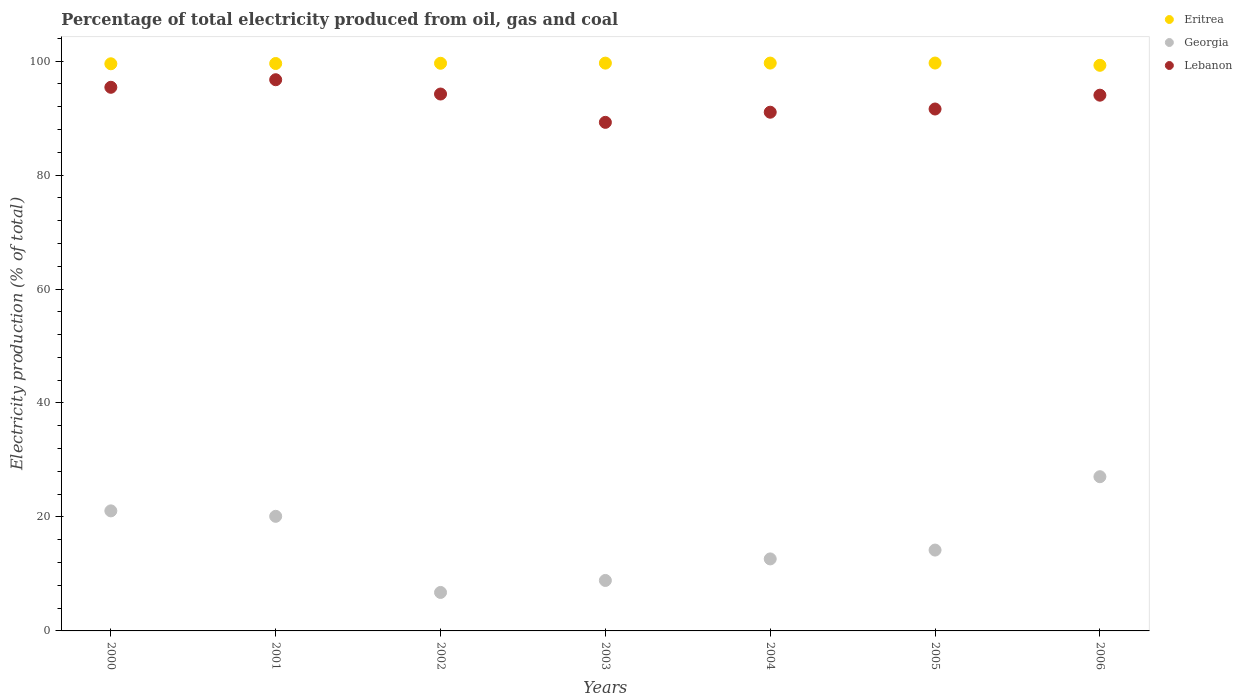How many different coloured dotlines are there?
Provide a short and direct response. 3. Is the number of dotlines equal to the number of legend labels?
Your answer should be very brief. Yes. What is the electricity production in in Eritrea in 2000?
Your answer should be compact. 99.52. Across all years, what is the maximum electricity production in in Georgia?
Provide a short and direct response. 27.06. Across all years, what is the minimum electricity production in in Lebanon?
Offer a very short reply. 89.25. In which year was the electricity production in in Lebanon maximum?
Ensure brevity in your answer.  2001. In which year was the electricity production in in Georgia minimum?
Give a very brief answer. 2002. What is the total electricity production in in Eritrea in the graph?
Give a very brief answer. 696.9. What is the difference between the electricity production in in Georgia in 2001 and that in 2006?
Your answer should be compact. -6.95. What is the difference between the electricity production in in Georgia in 2004 and the electricity production in in Eritrea in 2000?
Your answer should be compact. -86.89. What is the average electricity production in in Eritrea per year?
Offer a very short reply. 99.56. In the year 2001, what is the difference between the electricity production in in Lebanon and electricity production in in Georgia?
Offer a terse response. 76.62. What is the ratio of the electricity production in in Georgia in 2000 to that in 2004?
Make the answer very short. 1.67. Is the difference between the electricity production in in Lebanon in 2001 and 2003 greater than the difference between the electricity production in in Georgia in 2001 and 2003?
Your answer should be compact. No. What is the difference between the highest and the second highest electricity production in in Lebanon?
Provide a succinct answer. 1.33. What is the difference between the highest and the lowest electricity production in in Georgia?
Your answer should be compact. 20.31. In how many years, is the electricity production in in Georgia greater than the average electricity production in in Georgia taken over all years?
Keep it short and to the point. 3. Is it the case that in every year, the sum of the electricity production in in Georgia and electricity production in in Eritrea  is greater than the electricity production in in Lebanon?
Your answer should be very brief. Yes. Is the electricity production in in Eritrea strictly greater than the electricity production in in Lebanon over the years?
Make the answer very short. Yes. How many dotlines are there?
Ensure brevity in your answer.  3. How many years are there in the graph?
Offer a very short reply. 7. How many legend labels are there?
Your answer should be very brief. 3. What is the title of the graph?
Offer a terse response. Percentage of total electricity produced from oil, gas and coal. Does "France" appear as one of the legend labels in the graph?
Provide a short and direct response. No. What is the label or title of the Y-axis?
Offer a very short reply. Electricity production (% of total). What is the Electricity production (% of total) in Eritrea in 2000?
Keep it short and to the point. 99.52. What is the Electricity production (% of total) in Georgia in 2000?
Make the answer very short. 21.07. What is the Electricity production (% of total) in Lebanon in 2000?
Your answer should be compact. 95.4. What is the Electricity production (% of total) in Eritrea in 2001?
Offer a very short reply. 99.57. What is the Electricity production (% of total) in Georgia in 2001?
Make the answer very short. 20.11. What is the Electricity production (% of total) in Lebanon in 2001?
Your answer should be compact. 96.72. What is the Electricity production (% of total) of Eritrea in 2002?
Make the answer very short. 99.61. What is the Electricity production (% of total) in Georgia in 2002?
Offer a very short reply. 6.75. What is the Electricity production (% of total) in Lebanon in 2002?
Ensure brevity in your answer.  94.22. What is the Electricity production (% of total) in Eritrea in 2003?
Your answer should be very brief. 99.64. What is the Electricity production (% of total) of Georgia in 2003?
Provide a short and direct response. 8.85. What is the Electricity production (% of total) in Lebanon in 2003?
Offer a very short reply. 89.25. What is the Electricity production (% of total) of Eritrea in 2004?
Your response must be concise. 99.65. What is the Electricity production (% of total) of Georgia in 2004?
Provide a succinct answer. 12.64. What is the Electricity production (% of total) of Lebanon in 2004?
Make the answer very short. 91.02. What is the Electricity production (% of total) of Eritrea in 2005?
Provide a short and direct response. 99.65. What is the Electricity production (% of total) in Georgia in 2005?
Your response must be concise. 14.19. What is the Electricity production (% of total) of Lebanon in 2005?
Your answer should be compact. 91.59. What is the Electricity production (% of total) of Eritrea in 2006?
Provide a short and direct response. 99.26. What is the Electricity production (% of total) of Georgia in 2006?
Give a very brief answer. 27.06. What is the Electricity production (% of total) of Lebanon in 2006?
Ensure brevity in your answer.  94.01. Across all years, what is the maximum Electricity production (% of total) of Eritrea?
Provide a short and direct response. 99.65. Across all years, what is the maximum Electricity production (% of total) of Georgia?
Give a very brief answer. 27.06. Across all years, what is the maximum Electricity production (% of total) in Lebanon?
Your answer should be compact. 96.72. Across all years, what is the minimum Electricity production (% of total) of Eritrea?
Make the answer very short. 99.26. Across all years, what is the minimum Electricity production (% of total) of Georgia?
Your answer should be very brief. 6.75. Across all years, what is the minimum Electricity production (% of total) in Lebanon?
Your response must be concise. 89.25. What is the total Electricity production (% of total) in Eritrea in the graph?
Make the answer very short. 696.9. What is the total Electricity production (% of total) in Georgia in the graph?
Make the answer very short. 110.67. What is the total Electricity production (% of total) in Lebanon in the graph?
Ensure brevity in your answer.  652.21. What is the difference between the Electricity production (% of total) of Eritrea in 2000 and that in 2001?
Your response must be concise. -0.05. What is the difference between the Electricity production (% of total) of Georgia in 2000 and that in 2001?
Offer a very short reply. 0.96. What is the difference between the Electricity production (% of total) of Lebanon in 2000 and that in 2001?
Provide a short and direct response. -1.33. What is the difference between the Electricity production (% of total) of Eritrea in 2000 and that in 2002?
Provide a short and direct response. -0.09. What is the difference between the Electricity production (% of total) in Georgia in 2000 and that in 2002?
Ensure brevity in your answer.  14.31. What is the difference between the Electricity production (% of total) of Lebanon in 2000 and that in 2002?
Provide a short and direct response. 1.18. What is the difference between the Electricity production (% of total) in Eritrea in 2000 and that in 2003?
Offer a very short reply. -0.12. What is the difference between the Electricity production (% of total) of Georgia in 2000 and that in 2003?
Offer a terse response. 12.21. What is the difference between the Electricity production (% of total) of Lebanon in 2000 and that in 2003?
Provide a short and direct response. 6.15. What is the difference between the Electricity production (% of total) of Eritrea in 2000 and that in 2004?
Provide a short and direct response. -0.12. What is the difference between the Electricity production (% of total) of Georgia in 2000 and that in 2004?
Provide a succinct answer. 8.43. What is the difference between the Electricity production (% of total) of Lebanon in 2000 and that in 2004?
Offer a terse response. 4.37. What is the difference between the Electricity production (% of total) in Eritrea in 2000 and that in 2005?
Make the answer very short. -0.13. What is the difference between the Electricity production (% of total) of Georgia in 2000 and that in 2005?
Make the answer very short. 6.88. What is the difference between the Electricity production (% of total) of Lebanon in 2000 and that in 2005?
Make the answer very short. 3.81. What is the difference between the Electricity production (% of total) of Eritrea in 2000 and that in 2006?
Offer a terse response. 0.27. What is the difference between the Electricity production (% of total) of Georgia in 2000 and that in 2006?
Keep it short and to the point. -6. What is the difference between the Electricity production (% of total) of Lebanon in 2000 and that in 2006?
Keep it short and to the point. 1.38. What is the difference between the Electricity production (% of total) in Eritrea in 2001 and that in 2002?
Give a very brief answer. -0.04. What is the difference between the Electricity production (% of total) in Georgia in 2001 and that in 2002?
Ensure brevity in your answer.  13.36. What is the difference between the Electricity production (% of total) of Lebanon in 2001 and that in 2002?
Make the answer very short. 2.51. What is the difference between the Electricity production (% of total) in Eritrea in 2001 and that in 2003?
Make the answer very short. -0.07. What is the difference between the Electricity production (% of total) in Georgia in 2001 and that in 2003?
Your answer should be very brief. 11.25. What is the difference between the Electricity production (% of total) in Lebanon in 2001 and that in 2003?
Keep it short and to the point. 7.48. What is the difference between the Electricity production (% of total) in Eritrea in 2001 and that in 2004?
Your response must be concise. -0.08. What is the difference between the Electricity production (% of total) of Georgia in 2001 and that in 2004?
Offer a terse response. 7.47. What is the difference between the Electricity production (% of total) in Lebanon in 2001 and that in 2004?
Offer a very short reply. 5.7. What is the difference between the Electricity production (% of total) in Eritrea in 2001 and that in 2005?
Make the answer very short. -0.08. What is the difference between the Electricity production (% of total) in Georgia in 2001 and that in 2005?
Offer a terse response. 5.92. What is the difference between the Electricity production (% of total) of Lebanon in 2001 and that in 2005?
Keep it short and to the point. 5.14. What is the difference between the Electricity production (% of total) in Eritrea in 2001 and that in 2006?
Keep it short and to the point. 0.31. What is the difference between the Electricity production (% of total) of Georgia in 2001 and that in 2006?
Your response must be concise. -6.95. What is the difference between the Electricity production (% of total) in Lebanon in 2001 and that in 2006?
Provide a succinct answer. 2.71. What is the difference between the Electricity production (% of total) of Eritrea in 2002 and that in 2003?
Give a very brief answer. -0.03. What is the difference between the Electricity production (% of total) of Georgia in 2002 and that in 2003?
Make the answer very short. -2.1. What is the difference between the Electricity production (% of total) in Lebanon in 2002 and that in 2003?
Provide a short and direct response. 4.97. What is the difference between the Electricity production (% of total) of Eritrea in 2002 and that in 2004?
Keep it short and to the point. -0.03. What is the difference between the Electricity production (% of total) in Georgia in 2002 and that in 2004?
Your answer should be very brief. -5.89. What is the difference between the Electricity production (% of total) in Lebanon in 2002 and that in 2004?
Give a very brief answer. 3.19. What is the difference between the Electricity production (% of total) in Eritrea in 2002 and that in 2005?
Make the answer very short. -0.04. What is the difference between the Electricity production (% of total) of Georgia in 2002 and that in 2005?
Your response must be concise. -7.44. What is the difference between the Electricity production (% of total) in Lebanon in 2002 and that in 2005?
Ensure brevity in your answer.  2.63. What is the difference between the Electricity production (% of total) of Eritrea in 2002 and that in 2006?
Offer a very short reply. 0.36. What is the difference between the Electricity production (% of total) of Georgia in 2002 and that in 2006?
Provide a succinct answer. -20.31. What is the difference between the Electricity production (% of total) in Lebanon in 2002 and that in 2006?
Give a very brief answer. 0.2. What is the difference between the Electricity production (% of total) of Eritrea in 2003 and that in 2004?
Your response must be concise. -0.01. What is the difference between the Electricity production (% of total) in Georgia in 2003 and that in 2004?
Provide a short and direct response. -3.78. What is the difference between the Electricity production (% of total) in Lebanon in 2003 and that in 2004?
Your answer should be compact. -1.78. What is the difference between the Electricity production (% of total) in Eritrea in 2003 and that in 2005?
Make the answer very short. -0.01. What is the difference between the Electricity production (% of total) of Georgia in 2003 and that in 2005?
Provide a succinct answer. -5.33. What is the difference between the Electricity production (% of total) of Lebanon in 2003 and that in 2005?
Provide a succinct answer. -2.34. What is the difference between the Electricity production (% of total) in Eritrea in 2003 and that in 2006?
Your answer should be very brief. 0.38. What is the difference between the Electricity production (% of total) of Georgia in 2003 and that in 2006?
Make the answer very short. -18.21. What is the difference between the Electricity production (% of total) of Lebanon in 2003 and that in 2006?
Provide a succinct answer. -4.77. What is the difference between the Electricity production (% of total) of Eritrea in 2004 and that in 2005?
Ensure brevity in your answer.  -0.01. What is the difference between the Electricity production (% of total) of Georgia in 2004 and that in 2005?
Your answer should be compact. -1.55. What is the difference between the Electricity production (% of total) in Lebanon in 2004 and that in 2005?
Ensure brevity in your answer.  -0.56. What is the difference between the Electricity production (% of total) in Eritrea in 2004 and that in 2006?
Ensure brevity in your answer.  0.39. What is the difference between the Electricity production (% of total) of Georgia in 2004 and that in 2006?
Provide a succinct answer. -14.42. What is the difference between the Electricity production (% of total) in Lebanon in 2004 and that in 2006?
Your answer should be very brief. -2.99. What is the difference between the Electricity production (% of total) in Eritrea in 2005 and that in 2006?
Your answer should be compact. 0.4. What is the difference between the Electricity production (% of total) of Georgia in 2005 and that in 2006?
Ensure brevity in your answer.  -12.87. What is the difference between the Electricity production (% of total) of Lebanon in 2005 and that in 2006?
Make the answer very short. -2.43. What is the difference between the Electricity production (% of total) of Eritrea in 2000 and the Electricity production (% of total) of Georgia in 2001?
Provide a succinct answer. 79.41. What is the difference between the Electricity production (% of total) in Eritrea in 2000 and the Electricity production (% of total) in Lebanon in 2001?
Provide a short and direct response. 2.8. What is the difference between the Electricity production (% of total) in Georgia in 2000 and the Electricity production (% of total) in Lebanon in 2001?
Keep it short and to the point. -75.66. What is the difference between the Electricity production (% of total) of Eritrea in 2000 and the Electricity production (% of total) of Georgia in 2002?
Your answer should be compact. 92.77. What is the difference between the Electricity production (% of total) of Eritrea in 2000 and the Electricity production (% of total) of Lebanon in 2002?
Keep it short and to the point. 5.31. What is the difference between the Electricity production (% of total) in Georgia in 2000 and the Electricity production (% of total) in Lebanon in 2002?
Your response must be concise. -73.15. What is the difference between the Electricity production (% of total) of Eritrea in 2000 and the Electricity production (% of total) of Georgia in 2003?
Provide a short and direct response. 90.67. What is the difference between the Electricity production (% of total) of Eritrea in 2000 and the Electricity production (% of total) of Lebanon in 2003?
Your response must be concise. 10.28. What is the difference between the Electricity production (% of total) of Georgia in 2000 and the Electricity production (% of total) of Lebanon in 2003?
Your answer should be compact. -68.18. What is the difference between the Electricity production (% of total) of Eritrea in 2000 and the Electricity production (% of total) of Georgia in 2004?
Make the answer very short. 86.89. What is the difference between the Electricity production (% of total) of Eritrea in 2000 and the Electricity production (% of total) of Lebanon in 2004?
Your answer should be compact. 8.5. What is the difference between the Electricity production (% of total) of Georgia in 2000 and the Electricity production (% of total) of Lebanon in 2004?
Provide a short and direct response. -69.96. What is the difference between the Electricity production (% of total) of Eritrea in 2000 and the Electricity production (% of total) of Georgia in 2005?
Your answer should be compact. 85.34. What is the difference between the Electricity production (% of total) of Eritrea in 2000 and the Electricity production (% of total) of Lebanon in 2005?
Offer a terse response. 7.94. What is the difference between the Electricity production (% of total) of Georgia in 2000 and the Electricity production (% of total) of Lebanon in 2005?
Make the answer very short. -70.52. What is the difference between the Electricity production (% of total) in Eritrea in 2000 and the Electricity production (% of total) in Georgia in 2006?
Your response must be concise. 72.46. What is the difference between the Electricity production (% of total) of Eritrea in 2000 and the Electricity production (% of total) of Lebanon in 2006?
Ensure brevity in your answer.  5.51. What is the difference between the Electricity production (% of total) of Georgia in 2000 and the Electricity production (% of total) of Lebanon in 2006?
Keep it short and to the point. -72.95. What is the difference between the Electricity production (% of total) in Eritrea in 2001 and the Electricity production (% of total) in Georgia in 2002?
Offer a very short reply. 92.82. What is the difference between the Electricity production (% of total) of Eritrea in 2001 and the Electricity production (% of total) of Lebanon in 2002?
Your response must be concise. 5.36. What is the difference between the Electricity production (% of total) of Georgia in 2001 and the Electricity production (% of total) of Lebanon in 2002?
Offer a very short reply. -74.11. What is the difference between the Electricity production (% of total) in Eritrea in 2001 and the Electricity production (% of total) in Georgia in 2003?
Offer a terse response. 90.72. What is the difference between the Electricity production (% of total) of Eritrea in 2001 and the Electricity production (% of total) of Lebanon in 2003?
Your answer should be compact. 10.33. What is the difference between the Electricity production (% of total) of Georgia in 2001 and the Electricity production (% of total) of Lebanon in 2003?
Offer a very short reply. -69.14. What is the difference between the Electricity production (% of total) of Eritrea in 2001 and the Electricity production (% of total) of Georgia in 2004?
Give a very brief answer. 86.93. What is the difference between the Electricity production (% of total) in Eritrea in 2001 and the Electricity production (% of total) in Lebanon in 2004?
Your answer should be very brief. 8.55. What is the difference between the Electricity production (% of total) in Georgia in 2001 and the Electricity production (% of total) in Lebanon in 2004?
Provide a short and direct response. -70.91. What is the difference between the Electricity production (% of total) of Eritrea in 2001 and the Electricity production (% of total) of Georgia in 2005?
Give a very brief answer. 85.38. What is the difference between the Electricity production (% of total) in Eritrea in 2001 and the Electricity production (% of total) in Lebanon in 2005?
Your response must be concise. 7.98. What is the difference between the Electricity production (% of total) of Georgia in 2001 and the Electricity production (% of total) of Lebanon in 2005?
Offer a terse response. -71.48. What is the difference between the Electricity production (% of total) of Eritrea in 2001 and the Electricity production (% of total) of Georgia in 2006?
Your response must be concise. 72.51. What is the difference between the Electricity production (% of total) in Eritrea in 2001 and the Electricity production (% of total) in Lebanon in 2006?
Provide a succinct answer. 5.56. What is the difference between the Electricity production (% of total) in Georgia in 2001 and the Electricity production (% of total) in Lebanon in 2006?
Give a very brief answer. -73.9. What is the difference between the Electricity production (% of total) in Eritrea in 2002 and the Electricity production (% of total) in Georgia in 2003?
Provide a succinct answer. 90.76. What is the difference between the Electricity production (% of total) of Eritrea in 2002 and the Electricity production (% of total) of Lebanon in 2003?
Offer a terse response. 10.37. What is the difference between the Electricity production (% of total) in Georgia in 2002 and the Electricity production (% of total) in Lebanon in 2003?
Keep it short and to the point. -82.49. What is the difference between the Electricity production (% of total) in Eritrea in 2002 and the Electricity production (% of total) in Georgia in 2004?
Your response must be concise. 86.98. What is the difference between the Electricity production (% of total) in Eritrea in 2002 and the Electricity production (% of total) in Lebanon in 2004?
Provide a succinct answer. 8.59. What is the difference between the Electricity production (% of total) of Georgia in 2002 and the Electricity production (% of total) of Lebanon in 2004?
Your answer should be very brief. -84.27. What is the difference between the Electricity production (% of total) in Eritrea in 2002 and the Electricity production (% of total) in Georgia in 2005?
Provide a short and direct response. 85.43. What is the difference between the Electricity production (% of total) of Eritrea in 2002 and the Electricity production (% of total) of Lebanon in 2005?
Provide a short and direct response. 8.03. What is the difference between the Electricity production (% of total) of Georgia in 2002 and the Electricity production (% of total) of Lebanon in 2005?
Give a very brief answer. -84.83. What is the difference between the Electricity production (% of total) of Eritrea in 2002 and the Electricity production (% of total) of Georgia in 2006?
Provide a short and direct response. 72.55. What is the difference between the Electricity production (% of total) of Eritrea in 2002 and the Electricity production (% of total) of Lebanon in 2006?
Your answer should be compact. 5.6. What is the difference between the Electricity production (% of total) of Georgia in 2002 and the Electricity production (% of total) of Lebanon in 2006?
Your answer should be very brief. -87.26. What is the difference between the Electricity production (% of total) in Eritrea in 2003 and the Electricity production (% of total) in Georgia in 2004?
Offer a very short reply. 87. What is the difference between the Electricity production (% of total) of Eritrea in 2003 and the Electricity production (% of total) of Lebanon in 2004?
Provide a short and direct response. 8.61. What is the difference between the Electricity production (% of total) of Georgia in 2003 and the Electricity production (% of total) of Lebanon in 2004?
Your answer should be very brief. -82.17. What is the difference between the Electricity production (% of total) of Eritrea in 2003 and the Electricity production (% of total) of Georgia in 2005?
Offer a very short reply. 85.45. What is the difference between the Electricity production (% of total) of Eritrea in 2003 and the Electricity production (% of total) of Lebanon in 2005?
Provide a succinct answer. 8.05. What is the difference between the Electricity production (% of total) of Georgia in 2003 and the Electricity production (% of total) of Lebanon in 2005?
Offer a very short reply. -82.73. What is the difference between the Electricity production (% of total) in Eritrea in 2003 and the Electricity production (% of total) in Georgia in 2006?
Provide a short and direct response. 72.58. What is the difference between the Electricity production (% of total) of Eritrea in 2003 and the Electricity production (% of total) of Lebanon in 2006?
Your answer should be very brief. 5.63. What is the difference between the Electricity production (% of total) of Georgia in 2003 and the Electricity production (% of total) of Lebanon in 2006?
Provide a succinct answer. -85.16. What is the difference between the Electricity production (% of total) in Eritrea in 2004 and the Electricity production (% of total) in Georgia in 2005?
Make the answer very short. 85.46. What is the difference between the Electricity production (% of total) in Eritrea in 2004 and the Electricity production (% of total) in Lebanon in 2005?
Give a very brief answer. 8.06. What is the difference between the Electricity production (% of total) in Georgia in 2004 and the Electricity production (% of total) in Lebanon in 2005?
Provide a succinct answer. -78.95. What is the difference between the Electricity production (% of total) in Eritrea in 2004 and the Electricity production (% of total) in Georgia in 2006?
Make the answer very short. 72.58. What is the difference between the Electricity production (% of total) in Eritrea in 2004 and the Electricity production (% of total) in Lebanon in 2006?
Give a very brief answer. 5.63. What is the difference between the Electricity production (% of total) of Georgia in 2004 and the Electricity production (% of total) of Lebanon in 2006?
Ensure brevity in your answer.  -81.38. What is the difference between the Electricity production (% of total) in Eritrea in 2005 and the Electricity production (% of total) in Georgia in 2006?
Ensure brevity in your answer.  72.59. What is the difference between the Electricity production (% of total) in Eritrea in 2005 and the Electricity production (% of total) in Lebanon in 2006?
Your answer should be very brief. 5.64. What is the difference between the Electricity production (% of total) in Georgia in 2005 and the Electricity production (% of total) in Lebanon in 2006?
Ensure brevity in your answer.  -79.83. What is the average Electricity production (% of total) in Eritrea per year?
Your response must be concise. 99.56. What is the average Electricity production (% of total) of Georgia per year?
Your response must be concise. 15.81. What is the average Electricity production (% of total) in Lebanon per year?
Give a very brief answer. 93.17. In the year 2000, what is the difference between the Electricity production (% of total) of Eritrea and Electricity production (% of total) of Georgia?
Your answer should be very brief. 78.46. In the year 2000, what is the difference between the Electricity production (% of total) in Eritrea and Electricity production (% of total) in Lebanon?
Ensure brevity in your answer.  4.13. In the year 2000, what is the difference between the Electricity production (% of total) in Georgia and Electricity production (% of total) in Lebanon?
Offer a terse response. -74.33. In the year 2001, what is the difference between the Electricity production (% of total) in Eritrea and Electricity production (% of total) in Georgia?
Ensure brevity in your answer.  79.46. In the year 2001, what is the difference between the Electricity production (% of total) of Eritrea and Electricity production (% of total) of Lebanon?
Keep it short and to the point. 2.85. In the year 2001, what is the difference between the Electricity production (% of total) of Georgia and Electricity production (% of total) of Lebanon?
Your response must be concise. -76.62. In the year 2002, what is the difference between the Electricity production (% of total) of Eritrea and Electricity production (% of total) of Georgia?
Offer a very short reply. 92.86. In the year 2002, what is the difference between the Electricity production (% of total) of Eritrea and Electricity production (% of total) of Lebanon?
Ensure brevity in your answer.  5.4. In the year 2002, what is the difference between the Electricity production (% of total) in Georgia and Electricity production (% of total) in Lebanon?
Give a very brief answer. -87.46. In the year 2003, what is the difference between the Electricity production (% of total) in Eritrea and Electricity production (% of total) in Georgia?
Provide a succinct answer. 90.78. In the year 2003, what is the difference between the Electricity production (% of total) in Eritrea and Electricity production (% of total) in Lebanon?
Give a very brief answer. 10.39. In the year 2003, what is the difference between the Electricity production (% of total) of Georgia and Electricity production (% of total) of Lebanon?
Make the answer very short. -80.39. In the year 2004, what is the difference between the Electricity production (% of total) of Eritrea and Electricity production (% of total) of Georgia?
Offer a terse response. 87.01. In the year 2004, what is the difference between the Electricity production (% of total) in Eritrea and Electricity production (% of total) in Lebanon?
Give a very brief answer. 8.62. In the year 2004, what is the difference between the Electricity production (% of total) in Georgia and Electricity production (% of total) in Lebanon?
Give a very brief answer. -78.39. In the year 2005, what is the difference between the Electricity production (% of total) in Eritrea and Electricity production (% of total) in Georgia?
Provide a short and direct response. 85.47. In the year 2005, what is the difference between the Electricity production (% of total) in Eritrea and Electricity production (% of total) in Lebanon?
Ensure brevity in your answer.  8.07. In the year 2005, what is the difference between the Electricity production (% of total) in Georgia and Electricity production (% of total) in Lebanon?
Offer a terse response. -77.4. In the year 2006, what is the difference between the Electricity production (% of total) of Eritrea and Electricity production (% of total) of Georgia?
Your answer should be compact. 72.19. In the year 2006, what is the difference between the Electricity production (% of total) of Eritrea and Electricity production (% of total) of Lebanon?
Your answer should be very brief. 5.24. In the year 2006, what is the difference between the Electricity production (% of total) of Georgia and Electricity production (% of total) of Lebanon?
Offer a very short reply. -66.95. What is the ratio of the Electricity production (% of total) of Eritrea in 2000 to that in 2001?
Offer a terse response. 1. What is the ratio of the Electricity production (% of total) in Georgia in 2000 to that in 2001?
Your answer should be very brief. 1.05. What is the ratio of the Electricity production (% of total) in Lebanon in 2000 to that in 2001?
Your answer should be compact. 0.99. What is the ratio of the Electricity production (% of total) of Georgia in 2000 to that in 2002?
Offer a terse response. 3.12. What is the ratio of the Electricity production (% of total) of Lebanon in 2000 to that in 2002?
Offer a very short reply. 1.01. What is the ratio of the Electricity production (% of total) in Eritrea in 2000 to that in 2003?
Your answer should be very brief. 1. What is the ratio of the Electricity production (% of total) of Georgia in 2000 to that in 2003?
Provide a short and direct response. 2.38. What is the ratio of the Electricity production (% of total) of Lebanon in 2000 to that in 2003?
Offer a very short reply. 1.07. What is the ratio of the Electricity production (% of total) in Georgia in 2000 to that in 2004?
Keep it short and to the point. 1.67. What is the ratio of the Electricity production (% of total) of Lebanon in 2000 to that in 2004?
Provide a short and direct response. 1.05. What is the ratio of the Electricity production (% of total) of Georgia in 2000 to that in 2005?
Your answer should be compact. 1.48. What is the ratio of the Electricity production (% of total) of Lebanon in 2000 to that in 2005?
Keep it short and to the point. 1.04. What is the ratio of the Electricity production (% of total) of Eritrea in 2000 to that in 2006?
Your response must be concise. 1. What is the ratio of the Electricity production (% of total) in Georgia in 2000 to that in 2006?
Provide a succinct answer. 0.78. What is the ratio of the Electricity production (% of total) in Lebanon in 2000 to that in 2006?
Offer a very short reply. 1.01. What is the ratio of the Electricity production (% of total) in Georgia in 2001 to that in 2002?
Your response must be concise. 2.98. What is the ratio of the Electricity production (% of total) of Lebanon in 2001 to that in 2002?
Provide a short and direct response. 1.03. What is the ratio of the Electricity production (% of total) in Eritrea in 2001 to that in 2003?
Your answer should be compact. 1. What is the ratio of the Electricity production (% of total) in Georgia in 2001 to that in 2003?
Keep it short and to the point. 2.27. What is the ratio of the Electricity production (% of total) in Lebanon in 2001 to that in 2003?
Offer a very short reply. 1.08. What is the ratio of the Electricity production (% of total) of Eritrea in 2001 to that in 2004?
Give a very brief answer. 1. What is the ratio of the Electricity production (% of total) of Georgia in 2001 to that in 2004?
Provide a succinct answer. 1.59. What is the ratio of the Electricity production (% of total) in Lebanon in 2001 to that in 2004?
Make the answer very short. 1.06. What is the ratio of the Electricity production (% of total) in Georgia in 2001 to that in 2005?
Your answer should be very brief. 1.42. What is the ratio of the Electricity production (% of total) in Lebanon in 2001 to that in 2005?
Give a very brief answer. 1.06. What is the ratio of the Electricity production (% of total) of Eritrea in 2001 to that in 2006?
Give a very brief answer. 1. What is the ratio of the Electricity production (% of total) in Georgia in 2001 to that in 2006?
Your response must be concise. 0.74. What is the ratio of the Electricity production (% of total) of Lebanon in 2001 to that in 2006?
Your answer should be very brief. 1.03. What is the ratio of the Electricity production (% of total) of Eritrea in 2002 to that in 2003?
Your response must be concise. 1. What is the ratio of the Electricity production (% of total) in Georgia in 2002 to that in 2003?
Your answer should be very brief. 0.76. What is the ratio of the Electricity production (% of total) of Lebanon in 2002 to that in 2003?
Ensure brevity in your answer.  1.06. What is the ratio of the Electricity production (% of total) of Eritrea in 2002 to that in 2004?
Your response must be concise. 1. What is the ratio of the Electricity production (% of total) in Georgia in 2002 to that in 2004?
Offer a terse response. 0.53. What is the ratio of the Electricity production (% of total) in Lebanon in 2002 to that in 2004?
Ensure brevity in your answer.  1.04. What is the ratio of the Electricity production (% of total) in Georgia in 2002 to that in 2005?
Provide a succinct answer. 0.48. What is the ratio of the Electricity production (% of total) of Lebanon in 2002 to that in 2005?
Provide a short and direct response. 1.03. What is the ratio of the Electricity production (% of total) of Eritrea in 2002 to that in 2006?
Your answer should be compact. 1. What is the ratio of the Electricity production (% of total) of Georgia in 2002 to that in 2006?
Your answer should be very brief. 0.25. What is the ratio of the Electricity production (% of total) in Lebanon in 2002 to that in 2006?
Offer a very short reply. 1. What is the ratio of the Electricity production (% of total) of Georgia in 2003 to that in 2004?
Keep it short and to the point. 0.7. What is the ratio of the Electricity production (% of total) of Lebanon in 2003 to that in 2004?
Provide a succinct answer. 0.98. What is the ratio of the Electricity production (% of total) in Georgia in 2003 to that in 2005?
Offer a terse response. 0.62. What is the ratio of the Electricity production (% of total) of Lebanon in 2003 to that in 2005?
Offer a terse response. 0.97. What is the ratio of the Electricity production (% of total) of Eritrea in 2003 to that in 2006?
Provide a short and direct response. 1. What is the ratio of the Electricity production (% of total) of Georgia in 2003 to that in 2006?
Give a very brief answer. 0.33. What is the ratio of the Electricity production (% of total) of Lebanon in 2003 to that in 2006?
Give a very brief answer. 0.95. What is the ratio of the Electricity production (% of total) in Eritrea in 2004 to that in 2005?
Your answer should be very brief. 1. What is the ratio of the Electricity production (% of total) of Georgia in 2004 to that in 2005?
Give a very brief answer. 0.89. What is the ratio of the Electricity production (% of total) of Lebanon in 2004 to that in 2005?
Make the answer very short. 0.99. What is the ratio of the Electricity production (% of total) in Eritrea in 2004 to that in 2006?
Offer a very short reply. 1. What is the ratio of the Electricity production (% of total) of Georgia in 2004 to that in 2006?
Your answer should be compact. 0.47. What is the ratio of the Electricity production (% of total) of Lebanon in 2004 to that in 2006?
Make the answer very short. 0.97. What is the ratio of the Electricity production (% of total) in Georgia in 2005 to that in 2006?
Your answer should be very brief. 0.52. What is the ratio of the Electricity production (% of total) of Lebanon in 2005 to that in 2006?
Ensure brevity in your answer.  0.97. What is the difference between the highest and the second highest Electricity production (% of total) of Eritrea?
Give a very brief answer. 0.01. What is the difference between the highest and the second highest Electricity production (% of total) of Georgia?
Your response must be concise. 6. What is the difference between the highest and the second highest Electricity production (% of total) of Lebanon?
Keep it short and to the point. 1.33. What is the difference between the highest and the lowest Electricity production (% of total) of Eritrea?
Provide a short and direct response. 0.4. What is the difference between the highest and the lowest Electricity production (% of total) in Georgia?
Your response must be concise. 20.31. What is the difference between the highest and the lowest Electricity production (% of total) of Lebanon?
Your answer should be very brief. 7.48. 